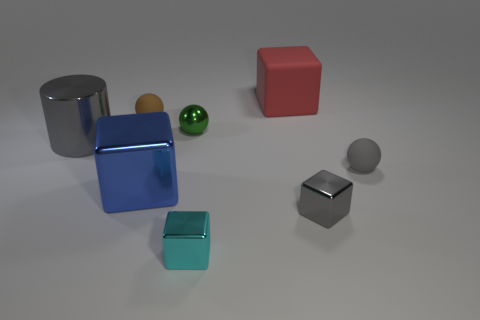What material is the gray object that is in front of the large cube in front of the gray metal thing that is left of the red thing?
Make the answer very short. Metal. There is a large cylinder; does it have the same color as the tiny matte sphere on the left side of the gray rubber ball?
Ensure brevity in your answer.  No. What number of objects are cubes behind the tiny gray block or big things in front of the large gray cylinder?
Your answer should be compact. 2. What is the shape of the gray object that is behind the ball that is right of the tiny metallic ball?
Provide a short and direct response. Cylinder. Are there any big purple spheres made of the same material as the blue cube?
Offer a terse response. No. What color is the other big metal object that is the same shape as the red thing?
Give a very brief answer. Blue. Are there fewer gray cylinders behind the red rubber cube than large cylinders to the right of the gray cylinder?
Keep it short and to the point. No. How many other things are there of the same shape as the big red rubber thing?
Provide a succinct answer. 3. Is the number of small spheres behind the shiny cylinder less than the number of big brown matte things?
Your response must be concise. No. What is the small gray thing behind the big blue thing made of?
Make the answer very short. Rubber. 